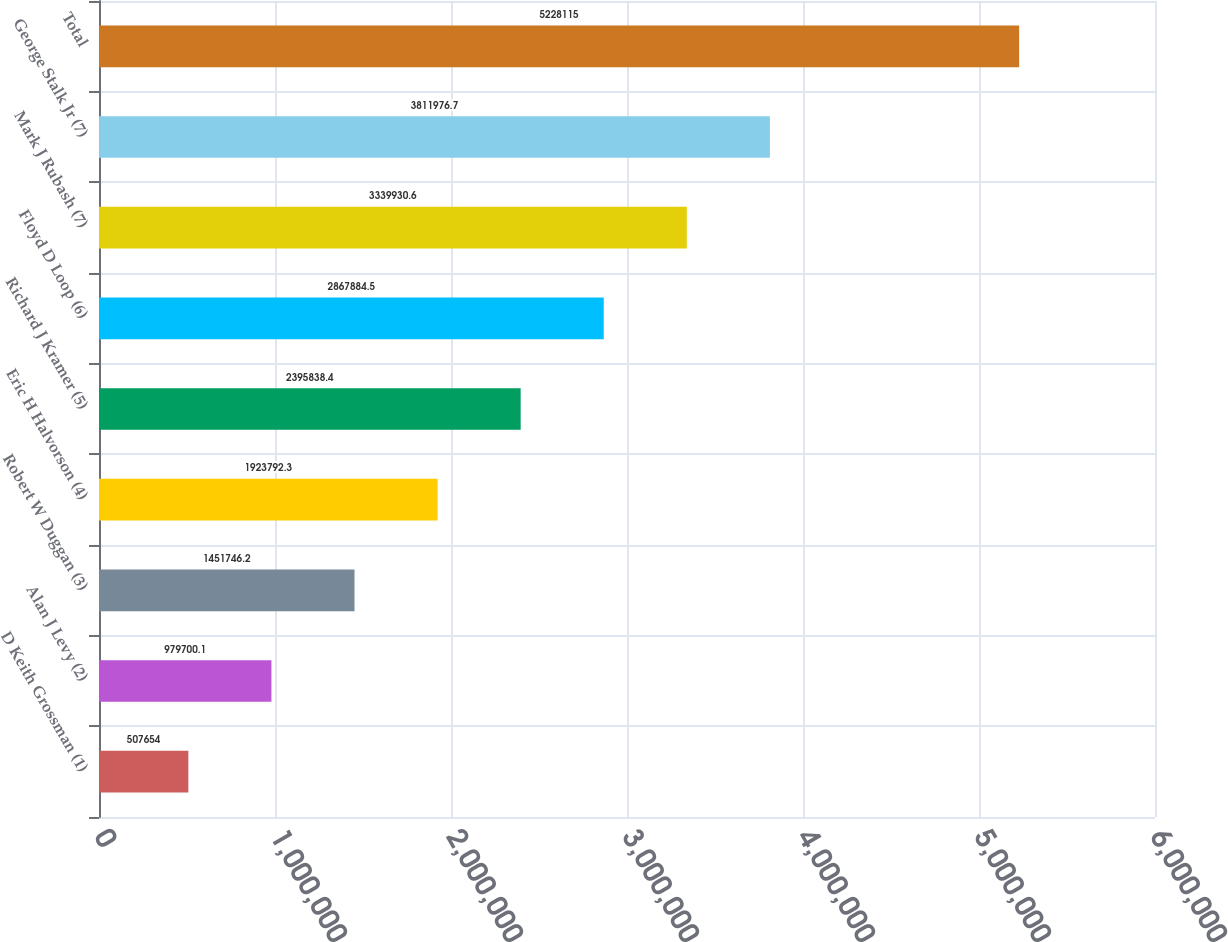Convert chart to OTSL. <chart><loc_0><loc_0><loc_500><loc_500><bar_chart><fcel>D Keith Grossman (1)<fcel>Alan J Levy (2)<fcel>Robert W Duggan (3)<fcel>Eric H Halvorson (4)<fcel>Richard J Kramer (5)<fcel>Floyd D Loop (6)<fcel>Mark J Rubash (7)<fcel>George Stalk Jr (7)<fcel>Total<nl><fcel>507654<fcel>979700<fcel>1.45175e+06<fcel>1.92379e+06<fcel>2.39584e+06<fcel>2.86788e+06<fcel>3.33993e+06<fcel>3.81198e+06<fcel>5.22812e+06<nl></chart> 